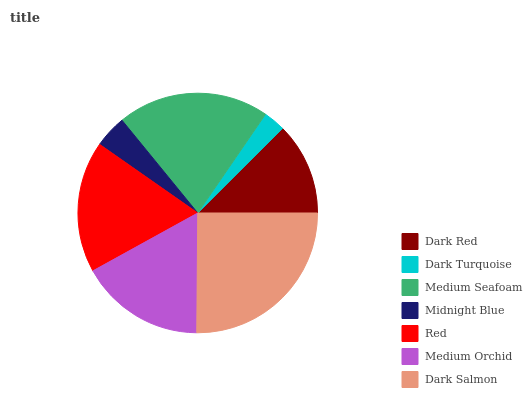Is Dark Turquoise the minimum?
Answer yes or no. Yes. Is Dark Salmon the maximum?
Answer yes or no. Yes. Is Medium Seafoam the minimum?
Answer yes or no. No. Is Medium Seafoam the maximum?
Answer yes or no. No. Is Medium Seafoam greater than Dark Turquoise?
Answer yes or no. Yes. Is Dark Turquoise less than Medium Seafoam?
Answer yes or no. Yes. Is Dark Turquoise greater than Medium Seafoam?
Answer yes or no. No. Is Medium Seafoam less than Dark Turquoise?
Answer yes or no. No. Is Medium Orchid the high median?
Answer yes or no. Yes. Is Medium Orchid the low median?
Answer yes or no. Yes. Is Medium Seafoam the high median?
Answer yes or no. No. Is Medium Seafoam the low median?
Answer yes or no. No. 